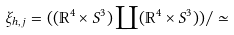<formula> <loc_0><loc_0><loc_500><loc_500>\xi _ { h , j } = ( ( \mathbb { R } ^ { 4 } \times S ^ { 3 } ) \coprod ( \mathbb { R } ^ { 4 } \times S ^ { 3 } ) ) / \simeq</formula> 